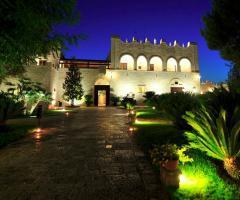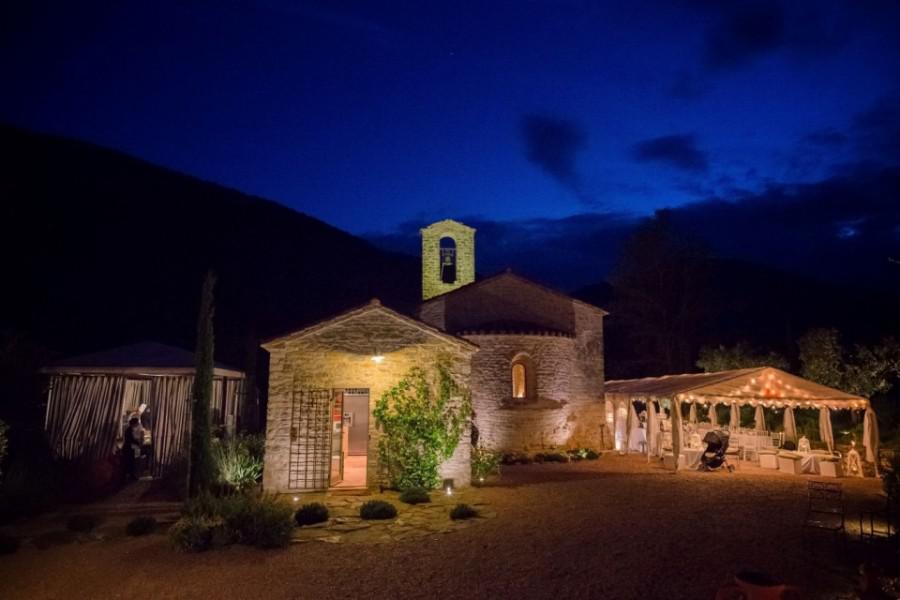The first image is the image on the left, the second image is the image on the right. Assess this claim about the two images: "There is a gazebo in one of the images.". Correct or not? Answer yes or no. Yes. 